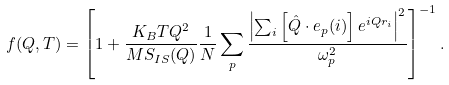Convert formula to latex. <formula><loc_0><loc_0><loc_500><loc_500>f ( Q , T ) = \left [ 1 + \frac { K _ { B } T Q ^ { 2 } } { M S _ { I S } ( Q ) } \frac { 1 } { N } \sum _ { p } { \frac { \left | \sum _ { i } \left [ \hat { Q } \cdot e _ { p } ( i ) \right ] e ^ { i Q r _ { i } } \right | ^ { 2 } } { \omega ^ { 2 } _ { p } } } \right ] ^ { - 1 } .</formula> 